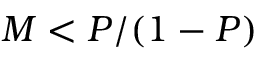<formula> <loc_0><loc_0><loc_500><loc_500>M < P / ( 1 - P )</formula> 